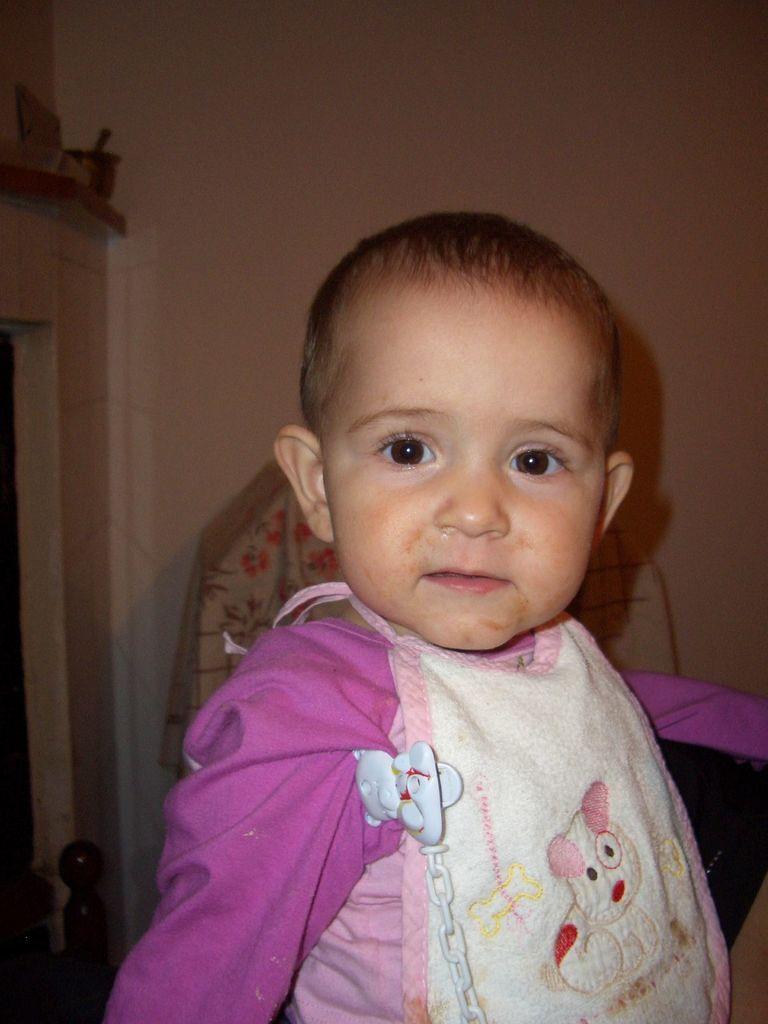Describe this image in one or two sentences. In this image in the front there is a kid. In the background there objects which are white and pink in colour and there is a wall which is white in colour. On the left side there is a cup on the shelf. 